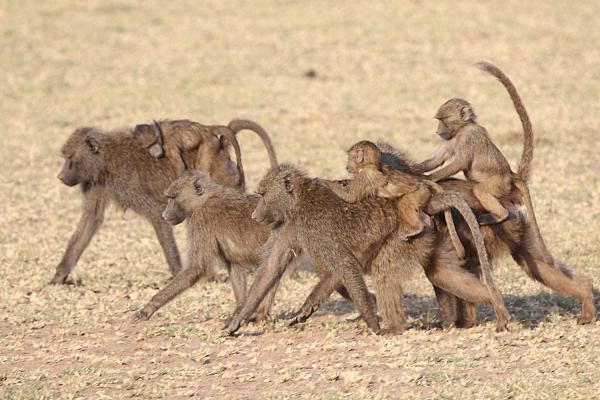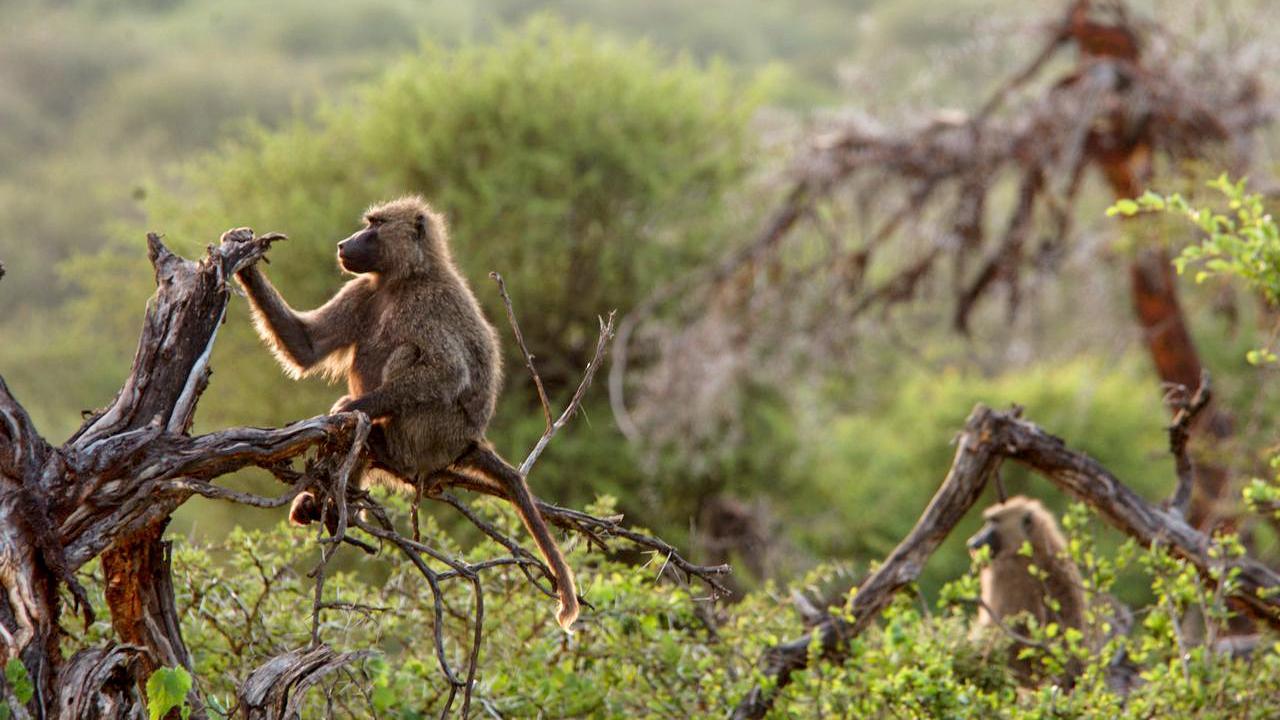The first image is the image on the left, the second image is the image on the right. Evaluate the accuracy of this statement regarding the images: "Some of the animals are on or near a dirt path.". Is it true? Answer yes or no. No. The first image is the image on the left, the second image is the image on the right. Considering the images on both sides, is "Right image includes no more than five baboons." valid? Answer yes or no. Yes. The first image is the image on the left, the second image is the image on the right. For the images shown, is this caption "At least one image shows monkeys that are walking in one direction." true? Answer yes or no. Yes. 